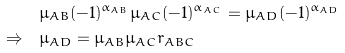Convert formula to latex. <formula><loc_0><loc_0><loc_500><loc_500>& \mu _ { A B } ( - 1 ) ^ { \alpha _ { A B } } \mu _ { A C } ( - 1 ) ^ { \alpha _ { A C } } = \mu _ { A D } ( - 1 ) ^ { \alpha _ { A D } } \\ \Rightarrow \quad & \mu _ { A D } = \mu _ { A B } \mu _ { A C } r _ { A B C }</formula> 